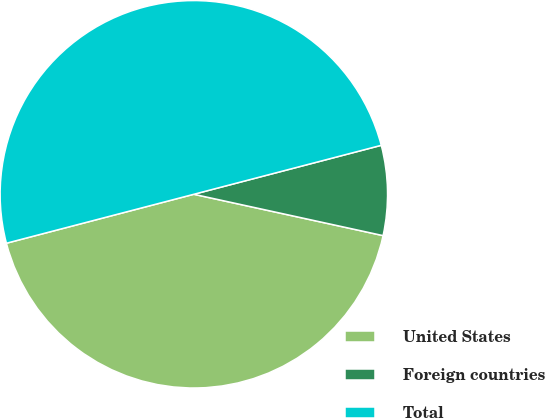<chart> <loc_0><loc_0><loc_500><loc_500><pie_chart><fcel>United States<fcel>Foreign countries<fcel>Total<nl><fcel>42.51%<fcel>7.49%<fcel>50.0%<nl></chart> 